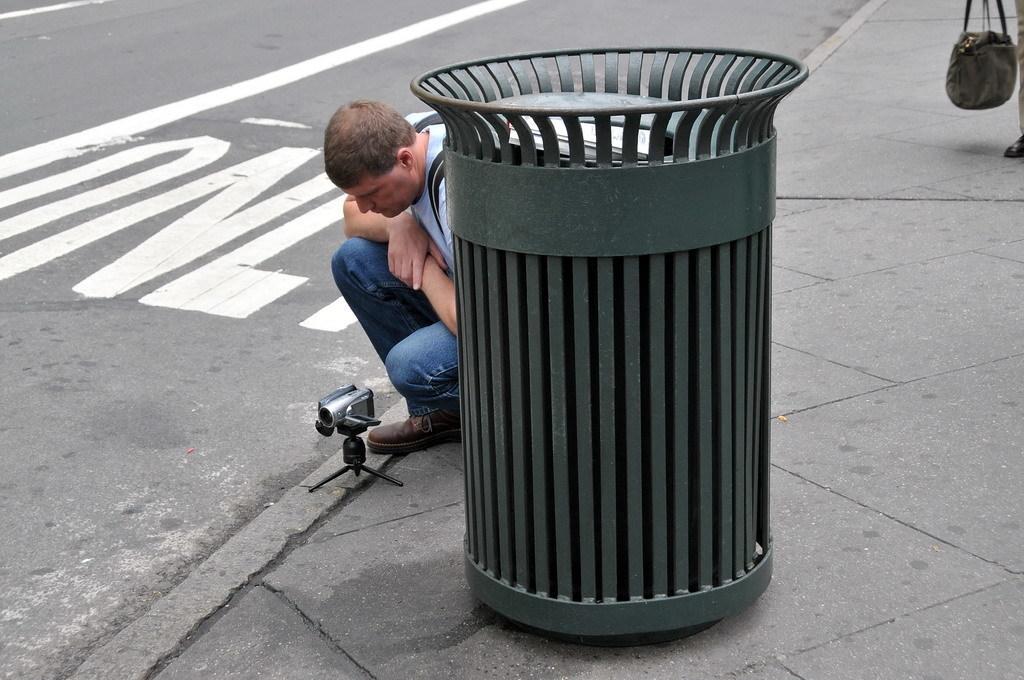How would you summarize this image in a sentence or two? This picture show about the black metal dustbin placed on the footpath. Behind we can see a man wearing white color t-shirt and blue jean sitting on the footpath with a small camera. In the background we can see big road with white marking. 